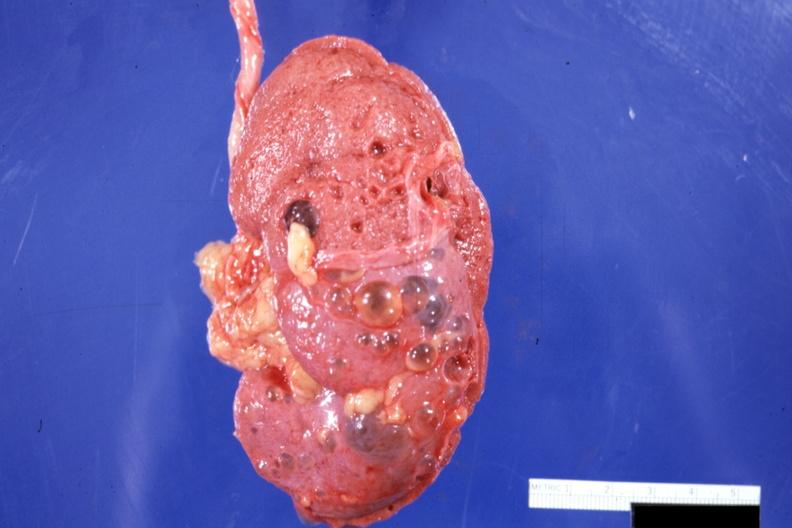where is this?
Answer the question using a single word or phrase. Urinary 